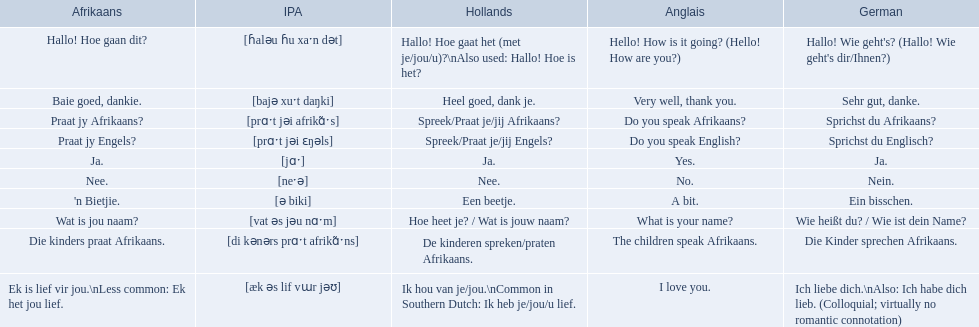What are the afrikaans phrases? Hallo! Hoe gaan dit?, Baie goed, dankie., Praat jy Afrikaans?, Praat jy Engels?, Ja., Nee., 'n Bietjie., Wat is jou naam?, Die kinders praat Afrikaans., Ek is lief vir jou.\nLess common: Ek het jou lief. For die kinders praat afrikaans, what are the translations? De kinderen spreken/praten Afrikaans., The children speak Afrikaans., Die Kinder sprechen Afrikaans. Can you parse all the data within this table? {'header': ['Afrikaans', 'IPA', 'Hollands', 'Anglais', 'German'], 'rows': [['Hallo! Hoe gaan dit?', '[ɦaləu ɦu xaˑn dət]', 'Hallo! Hoe gaat het (met je/jou/u)?\\nAlso used: Hallo! Hoe is het?', 'Hello! How is it going? (Hello! How are you?)', "Hallo! Wie geht's? (Hallo! Wie geht's dir/Ihnen?)"], ['Baie goed, dankie.', '[bajə xuˑt daŋki]', 'Heel goed, dank je.', 'Very well, thank you.', 'Sehr gut, danke.'], ['Praat jy Afrikaans?', '[prɑˑt jəi afrikɑ̃ˑs]', 'Spreek/Praat je/jij Afrikaans?', 'Do you speak Afrikaans?', 'Sprichst du Afrikaans?'], ['Praat jy Engels?', '[prɑˑt jəi ɛŋəls]', 'Spreek/Praat je/jij Engels?', 'Do you speak English?', 'Sprichst du Englisch?'], ['Ja.', '[jɑˑ]', 'Ja.', 'Yes.', 'Ja.'], ['Nee.', '[neˑə]', 'Nee.', 'No.', 'Nein.'], ["'n Bietjie.", '[ə biki]', 'Een beetje.', 'A bit.', 'Ein bisschen.'], ['Wat is jou naam?', '[vat əs jəu nɑˑm]', 'Hoe heet je? / Wat is jouw naam?', 'What is your name?', 'Wie heißt du? / Wie ist dein Name?'], ['Die kinders praat Afrikaans.', '[di kənərs prɑˑt afrikɑ̃ˑns]', 'De kinderen spreken/praten Afrikaans.', 'The children speak Afrikaans.', 'Die Kinder sprechen Afrikaans.'], ['Ek is lief vir jou.\\nLess common: Ek het jou lief.', '[æk əs lif vɯr jəʊ]', 'Ik hou van je/jou.\\nCommon in Southern Dutch: Ik heb je/jou/u lief.', 'I love you.', 'Ich liebe dich.\\nAlso: Ich habe dich lieb. (Colloquial; virtually no romantic connotation)']]} Which one is the german translation? Die Kinder sprechen Afrikaans. 